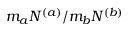Convert formula to latex. <formula><loc_0><loc_0><loc_500><loc_500>m _ { a } N ^ { ( a ) } / m _ { b } N ^ { ( b ) }</formula> 